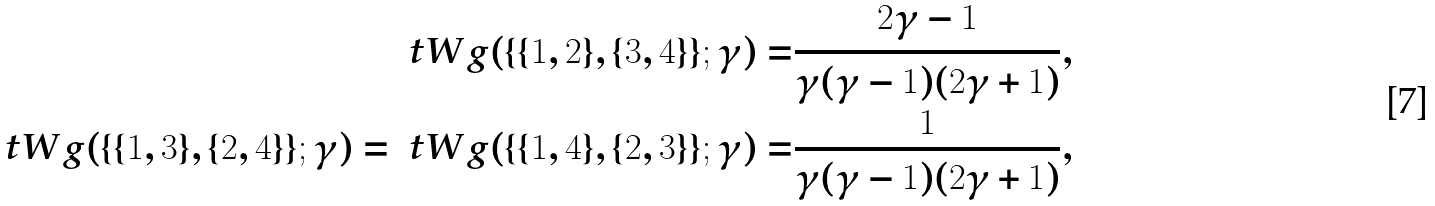<formula> <loc_0><loc_0><loc_500><loc_500>\ t W g ( \{ \{ 1 , 2 \} , \{ 3 , 4 \} \} ; \gamma ) = & \frac { 2 \gamma - 1 } { \gamma ( \gamma - 1 ) ( 2 \gamma + 1 ) } , \\ \ t W g ( \{ \{ 1 , 3 \} , \{ 2 , 4 \} \} ; \gamma ) = \ t W g ( \{ \{ 1 , 4 \} , \{ 2 , 3 \} \} ; \gamma ) = & \frac { 1 } { \gamma ( \gamma - 1 ) ( 2 \gamma + 1 ) } ,</formula> 